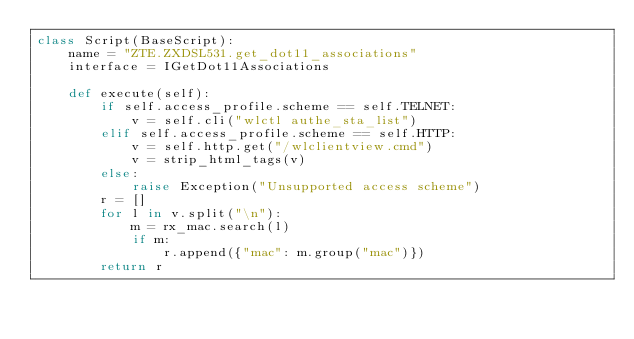Convert code to text. <code><loc_0><loc_0><loc_500><loc_500><_Python_>class Script(BaseScript):
    name = "ZTE.ZXDSL531.get_dot11_associations"
    interface = IGetDot11Associations

    def execute(self):
        if self.access_profile.scheme == self.TELNET:
            v = self.cli("wlctl authe_sta_list")
        elif self.access_profile.scheme == self.HTTP:
            v = self.http.get("/wlclientview.cmd")
            v = strip_html_tags(v)
        else:
            raise Exception("Unsupported access scheme")
        r = []
        for l in v.split("\n"):
            m = rx_mac.search(l)
            if m:
                r.append({"mac": m.group("mac")})
        return r
</code> 